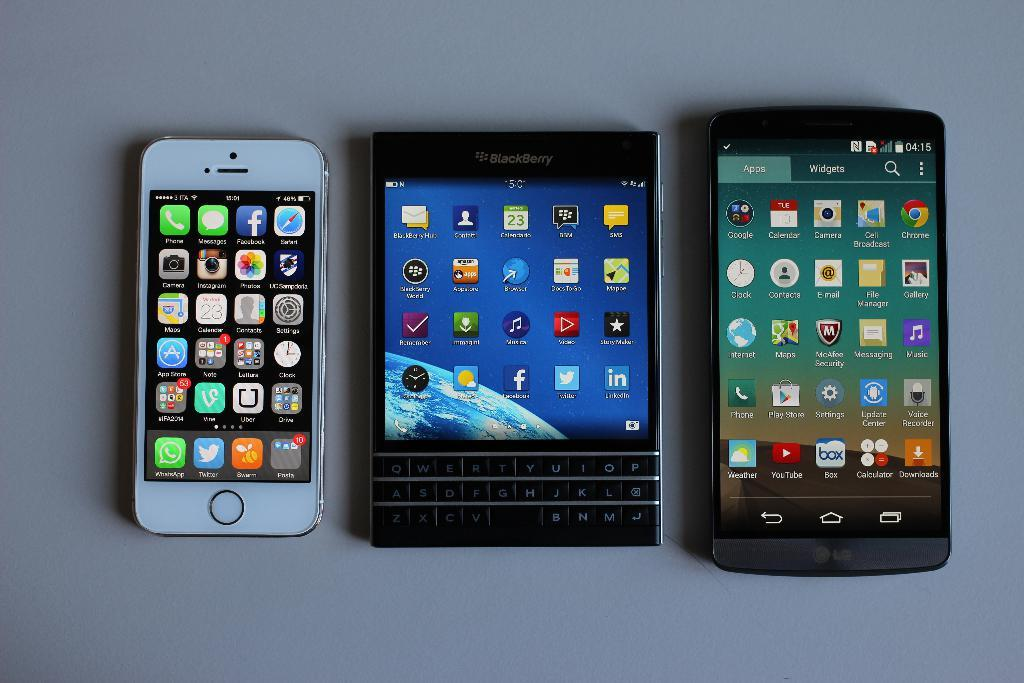<image>
Give a short and clear explanation of the subsequent image. A BlackBerry device sits on a table between an iPhone and another smart phone. 